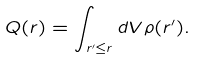Convert formula to latex. <formula><loc_0><loc_0><loc_500><loc_500>Q ( r ) = \int _ { r ^ { \prime } \leq r } d V \rho ( r ^ { \prime } ) .</formula> 